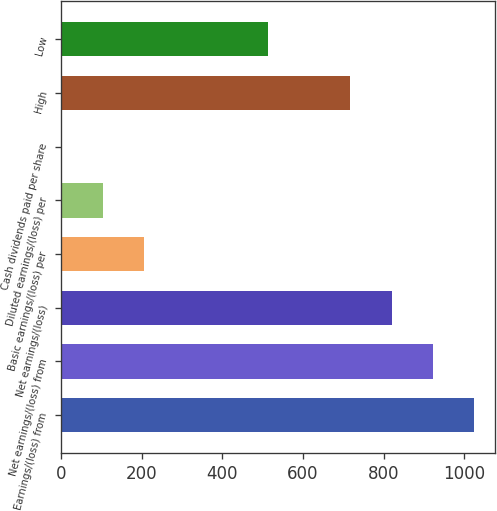<chart> <loc_0><loc_0><loc_500><loc_500><bar_chart><fcel>Earnings/(loss) from<fcel>Net earnings/(loss) from<fcel>Net earnings/(loss)<fcel>Basic earnings/(loss) per<fcel>Diluted earnings/(loss) per<fcel>Cash dividends paid per share<fcel>High<fcel>Low<nl><fcel>1025.02<fcel>922.56<fcel>820.1<fcel>205.34<fcel>102.88<fcel>0.42<fcel>717.64<fcel>512.72<nl></chart> 